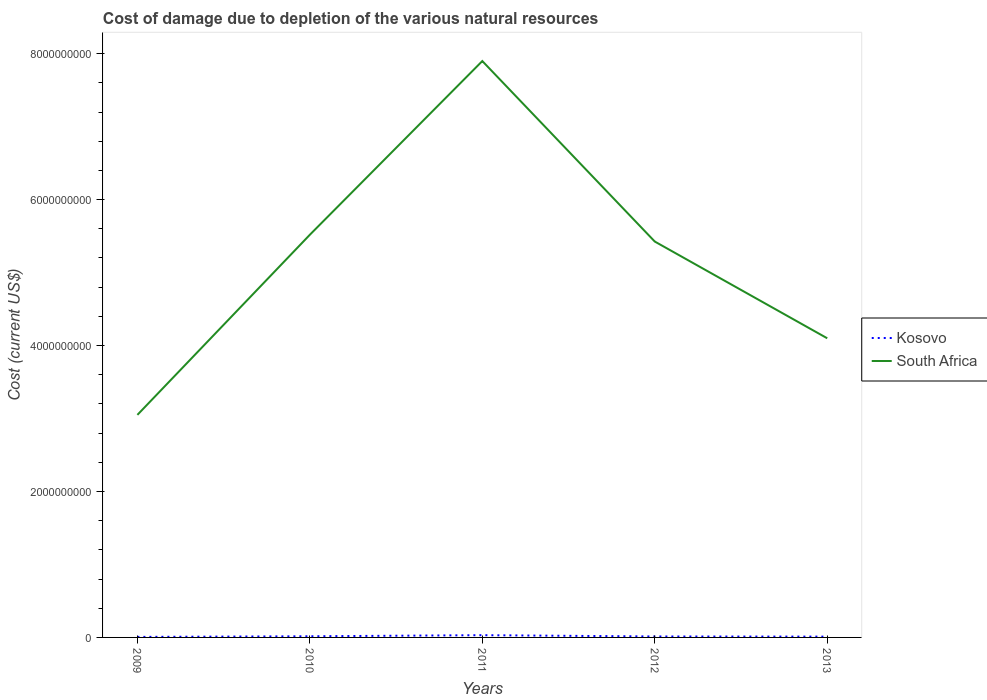How many different coloured lines are there?
Offer a terse response. 2. Is the number of lines equal to the number of legend labels?
Provide a succinct answer. Yes. Across all years, what is the maximum cost of damage caused due to the depletion of various natural resources in South Africa?
Keep it short and to the point. 3.05e+09. What is the total cost of damage caused due to the depletion of various natural resources in Kosovo in the graph?
Your answer should be compact. -2.37e+07. What is the difference between the highest and the second highest cost of damage caused due to the depletion of various natural resources in South Africa?
Offer a terse response. 4.85e+09. What is the difference between the highest and the lowest cost of damage caused due to the depletion of various natural resources in Kosovo?
Your response must be concise. 2. How many lines are there?
Your response must be concise. 2. How many years are there in the graph?
Provide a succinct answer. 5. How many legend labels are there?
Offer a very short reply. 2. How are the legend labels stacked?
Provide a short and direct response. Vertical. What is the title of the graph?
Your answer should be compact. Cost of damage due to depletion of the various natural resources. Does "New Zealand" appear as one of the legend labels in the graph?
Provide a succinct answer. No. What is the label or title of the X-axis?
Offer a very short reply. Years. What is the label or title of the Y-axis?
Keep it short and to the point. Cost (current US$). What is the Cost (current US$) in Kosovo in 2009?
Provide a succinct answer. 7.16e+06. What is the Cost (current US$) in South Africa in 2009?
Give a very brief answer. 3.05e+09. What is the Cost (current US$) of Kosovo in 2010?
Offer a terse response. 1.57e+07. What is the Cost (current US$) in South Africa in 2010?
Ensure brevity in your answer.  5.52e+09. What is the Cost (current US$) in Kosovo in 2011?
Keep it short and to the point. 3.08e+07. What is the Cost (current US$) of South Africa in 2011?
Your response must be concise. 7.90e+09. What is the Cost (current US$) of Kosovo in 2012?
Offer a terse response. 1.31e+07. What is the Cost (current US$) of South Africa in 2012?
Provide a short and direct response. 5.43e+09. What is the Cost (current US$) in Kosovo in 2013?
Your response must be concise. 1.10e+07. What is the Cost (current US$) in South Africa in 2013?
Provide a succinct answer. 4.10e+09. Across all years, what is the maximum Cost (current US$) of Kosovo?
Make the answer very short. 3.08e+07. Across all years, what is the maximum Cost (current US$) in South Africa?
Your answer should be very brief. 7.90e+09. Across all years, what is the minimum Cost (current US$) of Kosovo?
Make the answer very short. 7.16e+06. Across all years, what is the minimum Cost (current US$) in South Africa?
Keep it short and to the point. 3.05e+09. What is the total Cost (current US$) in Kosovo in the graph?
Give a very brief answer. 7.78e+07. What is the total Cost (current US$) in South Africa in the graph?
Offer a terse response. 2.60e+1. What is the difference between the Cost (current US$) of Kosovo in 2009 and that in 2010?
Your response must be concise. -8.56e+06. What is the difference between the Cost (current US$) of South Africa in 2009 and that in 2010?
Provide a short and direct response. -2.47e+09. What is the difference between the Cost (current US$) in Kosovo in 2009 and that in 2011?
Ensure brevity in your answer.  -2.37e+07. What is the difference between the Cost (current US$) in South Africa in 2009 and that in 2011?
Provide a succinct answer. -4.85e+09. What is the difference between the Cost (current US$) in Kosovo in 2009 and that in 2012?
Offer a very short reply. -5.94e+06. What is the difference between the Cost (current US$) in South Africa in 2009 and that in 2012?
Ensure brevity in your answer.  -2.38e+09. What is the difference between the Cost (current US$) in Kosovo in 2009 and that in 2013?
Provide a succinct answer. -3.83e+06. What is the difference between the Cost (current US$) of South Africa in 2009 and that in 2013?
Offer a terse response. -1.05e+09. What is the difference between the Cost (current US$) in Kosovo in 2010 and that in 2011?
Make the answer very short. -1.51e+07. What is the difference between the Cost (current US$) in South Africa in 2010 and that in 2011?
Offer a very short reply. -2.38e+09. What is the difference between the Cost (current US$) of Kosovo in 2010 and that in 2012?
Provide a short and direct response. 2.62e+06. What is the difference between the Cost (current US$) of South Africa in 2010 and that in 2012?
Provide a short and direct response. 9.31e+07. What is the difference between the Cost (current US$) in Kosovo in 2010 and that in 2013?
Provide a succinct answer. 4.73e+06. What is the difference between the Cost (current US$) of South Africa in 2010 and that in 2013?
Your answer should be compact. 1.42e+09. What is the difference between the Cost (current US$) of Kosovo in 2011 and that in 2012?
Your answer should be very brief. 1.77e+07. What is the difference between the Cost (current US$) of South Africa in 2011 and that in 2012?
Keep it short and to the point. 2.47e+09. What is the difference between the Cost (current US$) in Kosovo in 2011 and that in 2013?
Your response must be concise. 1.98e+07. What is the difference between the Cost (current US$) in South Africa in 2011 and that in 2013?
Offer a very short reply. 3.80e+09. What is the difference between the Cost (current US$) in Kosovo in 2012 and that in 2013?
Your answer should be compact. 2.11e+06. What is the difference between the Cost (current US$) of South Africa in 2012 and that in 2013?
Your response must be concise. 1.33e+09. What is the difference between the Cost (current US$) in Kosovo in 2009 and the Cost (current US$) in South Africa in 2010?
Your answer should be very brief. -5.51e+09. What is the difference between the Cost (current US$) in Kosovo in 2009 and the Cost (current US$) in South Africa in 2011?
Ensure brevity in your answer.  -7.89e+09. What is the difference between the Cost (current US$) in Kosovo in 2009 and the Cost (current US$) in South Africa in 2012?
Keep it short and to the point. -5.42e+09. What is the difference between the Cost (current US$) of Kosovo in 2009 and the Cost (current US$) of South Africa in 2013?
Your response must be concise. -4.09e+09. What is the difference between the Cost (current US$) in Kosovo in 2010 and the Cost (current US$) in South Africa in 2011?
Provide a short and direct response. -7.88e+09. What is the difference between the Cost (current US$) of Kosovo in 2010 and the Cost (current US$) of South Africa in 2012?
Your answer should be compact. -5.41e+09. What is the difference between the Cost (current US$) of Kosovo in 2010 and the Cost (current US$) of South Africa in 2013?
Offer a terse response. -4.08e+09. What is the difference between the Cost (current US$) in Kosovo in 2011 and the Cost (current US$) in South Africa in 2012?
Your answer should be compact. -5.39e+09. What is the difference between the Cost (current US$) in Kosovo in 2011 and the Cost (current US$) in South Africa in 2013?
Your response must be concise. -4.07e+09. What is the difference between the Cost (current US$) in Kosovo in 2012 and the Cost (current US$) in South Africa in 2013?
Your answer should be compact. -4.09e+09. What is the average Cost (current US$) in Kosovo per year?
Your answer should be very brief. 1.56e+07. What is the average Cost (current US$) in South Africa per year?
Offer a very short reply. 5.20e+09. In the year 2009, what is the difference between the Cost (current US$) in Kosovo and Cost (current US$) in South Africa?
Offer a very short reply. -3.04e+09. In the year 2010, what is the difference between the Cost (current US$) of Kosovo and Cost (current US$) of South Africa?
Provide a succinct answer. -5.50e+09. In the year 2011, what is the difference between the Cost (current US$) in Kosovo and Cost (current US$) in South Africa?
Offer a very short reply. -7.87e+09. In the year 2012, what is the difference between the Cost (current US$) in Kosovo and Cost (current US$) in South Africa?
Give a very brief answer. -5.41e+09. In the year 2013, what is the difference between the Cost (current US$) of Kosovo and Cost (current US$) of South Africa?
Ensure brevity in your answer.  -4.09e+09. What is the ratio of the Cost (current US$) of Kosovo in 2009 to that in 2010?
Provide a short and direct response. 0.46. What is the ratio of the Cost (current US$) in South Africa in 2009 to that in 2010?
Make the answer very short. 0.55. What is the ratio of the Cost (current US$) in Kosovo in 2009 to that in 2011?
Provide a short and direct response. 0.23. What is the ratio of the Cost (current US$) of South Africa in 2009 to that in 2011?
Give a very brief answer. 0.39. What is the ratio of the Cost (current US$) in Kosovo in 2009 to that in 2012?
Your answer should be very brief. 0.55. What is the ratio of the Cost (current US$) of South Africa in 2009 to that in 2012?
Your answer should be very brief. 0.56. What is the ratio of the Cost (current US$) in Kosovo in 2009 to that in 2013?
Offer a very short reply. 0.65. What is the ratio of the Cost (current US$) of South Africa in 2009 to that in 2013?
Provide a short and direct response. 0.74. What is the ratio of the Cost (current US$) of Kosovo in 2010 to that in 2011?
Your answer should be compact. 0.51. What is the ratio of the Cost (current US$) in South Africa in 2010 to that in 2011?
Ensure brevity in your answer.  0.7. What is the ratio of the Cost (current US$) of Kosovo in 2010 to that in 2012?
Ensure brevity in your answer.  1.2. What is the ratio of the Cost (current US$) in South Africa in 2010 to that in 2012?
Ensure brevity in your answer.  1.02. What is the ratio of the Cost (current US$) of Kosovo in 2010 to that in 2013?
Offer a terse response. 1.43. What is the ratio of the Cost (current US$) of South Africa in 2010 to that in 2013?
Offer a terse response. 1.35. What is the ratio of the Cost (current US$) of Kosovo in 2011 to that in 2012?
Provide a short and direct response. 2.35. What is the ratio of the Cost (current US$) in South Africa in 2011 to that in 2012?
Ensure brevity in your answer.  1.46. What is the ratio of the Cost (current US$) of Kosovo in 2011 to that in 2013?
Your response must be concise. 2.81. What is the ratio of the Cost (current US$) in South Africa in 2011 to that in 2013?
Make the answer very short. 1.93. What is the ratio of the Cost (current US$) in Kosovo in 2012 to that in 2013?
Ensure brevity in your answer.  1.19. What is the ratio of the Cost (current US$) in South Africa in 2012 to that in 2013?
Ensure brevity in your answer.  1.32. What is the difference between the highest and the second highest Cost (current US$) in Kosovo?
Keep it short and to the point. 1.51e+07. What is the difference between the highest and the second highest Cost (current US$) of South Africa?
Keep it short and to the point. 2.38e+09. What is the difference between the highest and the lowest Cost (current US$) in Kosovo?
Your answer should be compact. 2.37e+07. What is the difference between the highest and the lowest Cost (current US$) in South Africa?
Keep it short and to the point. 4.85e+09. 